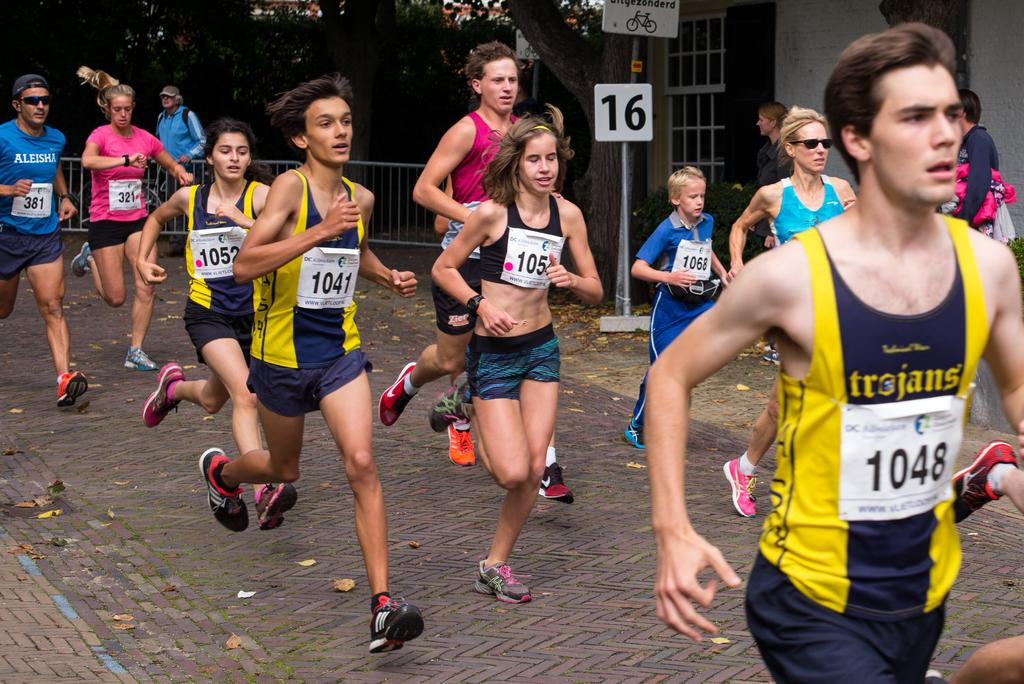What are the people in the image doing? The people in the image are running. What can be seen in the image besides the people running? There is a stand, a fence, and trees visible in the image. What type of society is depicted in the image? The image does not depict a society; it shows people running, a stand, a fence, and trees. What country is the image taken in? The image does not provide any information about the country it was taken in. 